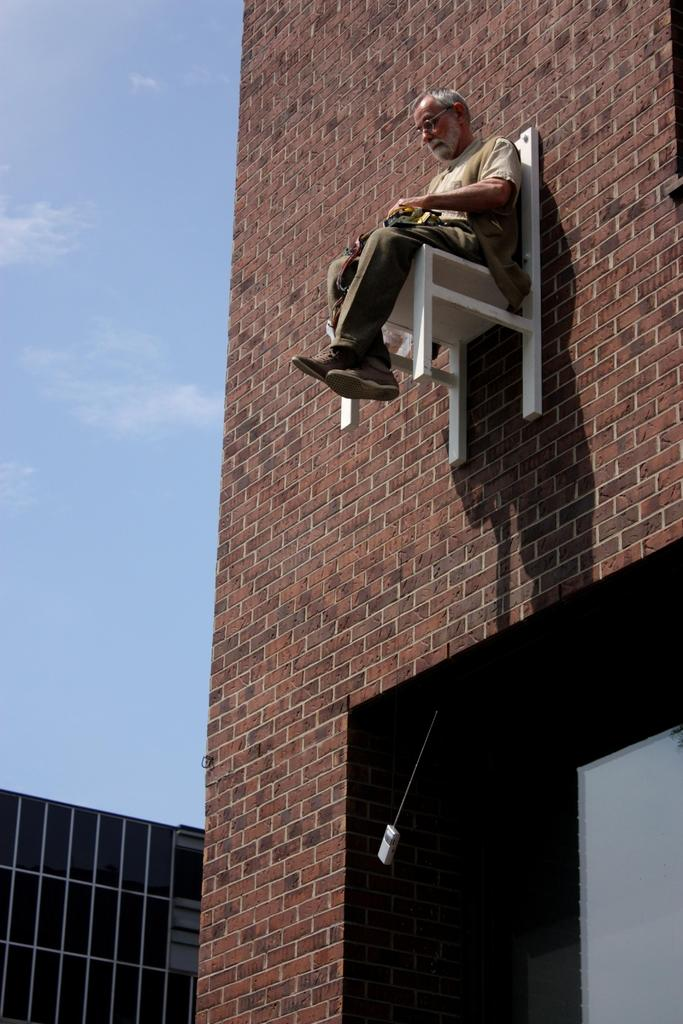What is the man in the image doing? The man is sitting on a chair in the image. How is the chair positioned in the image? The chair is attached to a wall in the image. What can be seen on the left side of the image? The sky is visible on the left side of the image. What type of clothing is the man wearing on his upper body? The man is wearing a shirt in the image. What type of clothing is the man wearing on his lower body? The man is wearing trousers in the image. What type of footwear is the man wearing? The man is wearing shoes in the image. Can you see a kitty playing with a paintbrush on the wall in the image? There is no kitty or paintbrush present on the wall in the image. What type of beast is hiding behind the man in the image? There is no beast present behind the man in the image. 